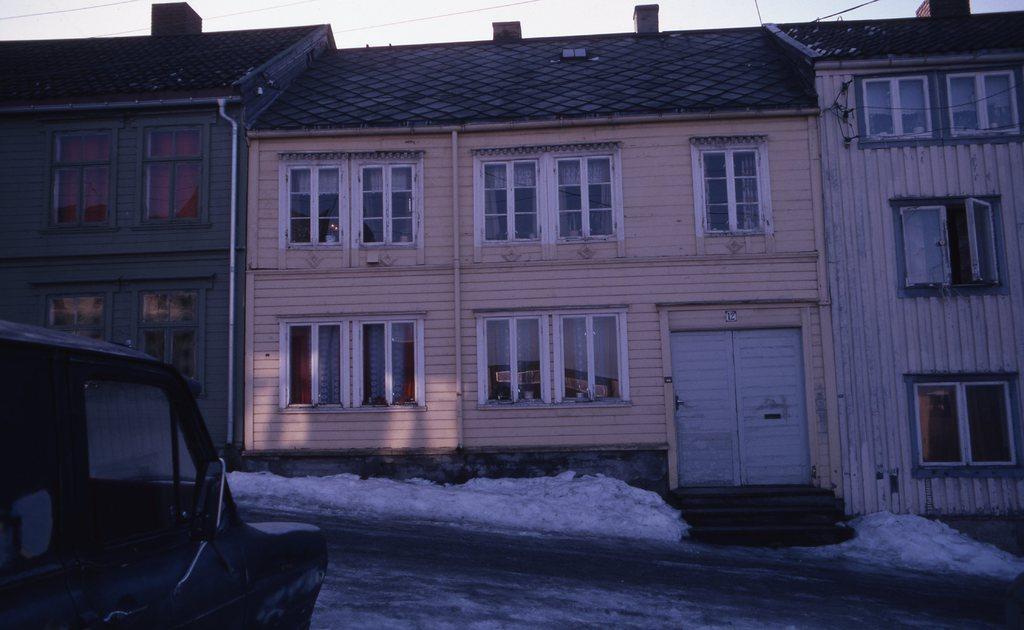Please provide a concise description of this image. In the image there is a building in the front with many windows with a car in front of it on the road and above its sky. 